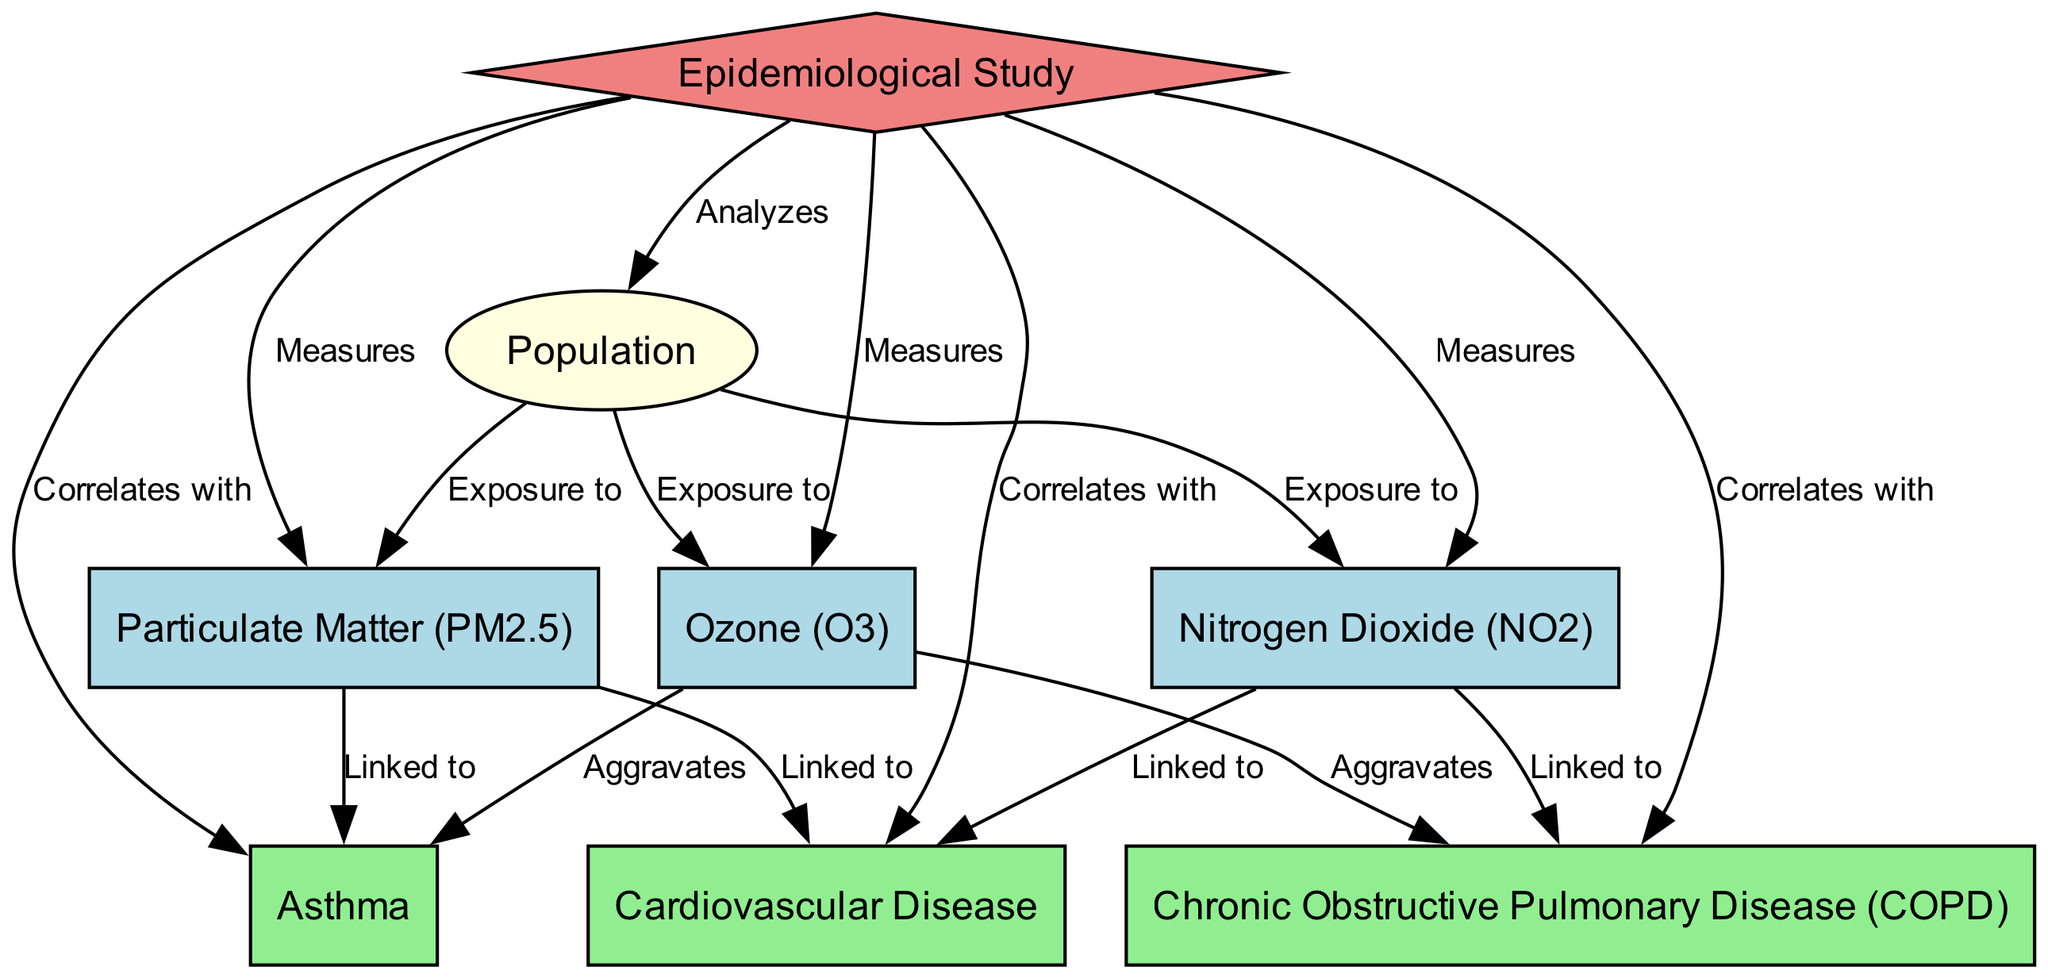What is the total number of nodes in the diagram? The diagram consists of 8 nodes: 1 population node, 3 pollutant nodes, 3 health condition nodes, and 1 study node. Therefore, the total is 8.
Answer: 8 What type of health condition is linked to Particulate Matter (PM2.5)? According to the edges, both Asthma and Cardiovascular Disease are linked to Particulate Matter (PM2.5).
Answer: Asthma, Cardiovascular Disease Which health condition does Ozone (O3) aggravate? The diagram indicates that Ozone (O3) aggravates both Asthma and Chronic Obstructive Pulmonary Disease (COPD).
Answer: Asthma, Chronic Obstructive Pulmonary Disease What relationship does the Epidemiological Study have with the Population? The Epidemiological Study analyzes the Population, as indicated by the respective edge connecting both nodes.
Answer: Analyzes Which pollutant is correlated with Chronic Obstructive Pulmonary Disease (COPD)? The edges show that both Nitrogen Dioxide (NO2) and Ozone (O3) have a correlation with Chronic Obstructive Pulmonary Disease (COPD).
Answer: Nitrogen Dioxide, Ozone How many edges are linked to the health condition "Cardiovascular Disease"? The edges indicate that Cardiovascular Disease is linked to two pollutants: Particulate Matter (PM2.5) and Nitrogen Dioxide (NO2). Thus, there are 2 edges linked to this health condition.
Answer: 2 Which pollutant is linked to the most health conditions? Particulate Matter (PM2.5) is linked to two health conditions: Asthma and Cardiovascular Disease. In comparison, Nitrogen Dioxide (NO2) is also linked to two health conditions, while Ozone (O3) aggravates two conditions. All pollutants are linked to two conditions each; therefore, no single pollutant is more connected.
Answer: None What does the edge labeled "Measures" connect the Epidemiological Study to? The edge labeled "Measures" shows connections between the Epidemiological Study and all three pollutants: Particulate Matter (PM2.5), Nitrogen Dioxide (NO2), and Ozone (O3).
Answer: Particulate Matter, Nitrogen Dioxide, Ozone How does Nitrogen Dioxide (NO2) impact Chronic Obstructive Pulmonary Disease (COPD)? The edge indicates that Nitrogen Dioxide (NO2) is directly linked to Chronic Obstructive Pulmonary Disease (COPD), suggesting a negative health impact.
Answer: Linked to 